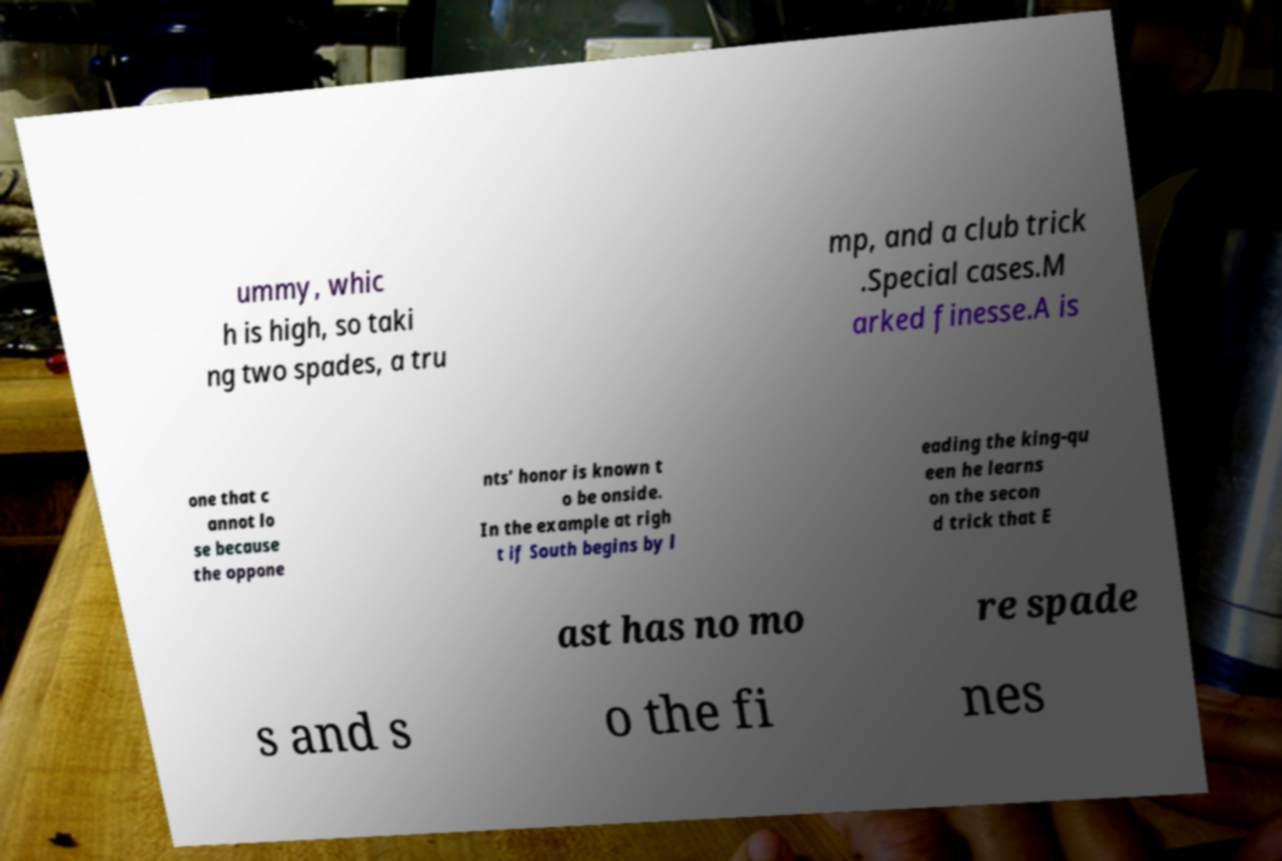For documentation purposes, I need the text within this image transcribed. Could you provide that? ummy, whic h is high, so taki ng two spades, a tru mp, and a club trick .Special cases.M arked finesse.A is one that c annot lo se because the oppone nts' honor is known t o be onside. In the example at righ t if South begins by l eading the king-qu een he learns on the secon d trick that E ast has no mo re spade s and s o the fi nes 